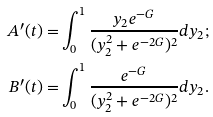Convert formula to latex. <formula><loc_0><loc_0><loc_500><loc_500>A ^ { \prime } ( t ) = & \int _ { 0 } ^ { 1 } \frac { y _ { 2 } e ^ { - G } } { ( y _ { 2 } ^ { 2 } + e ^ { - 2 G } ) ^ { 2 } } d y _ { 2 } ; \\ B ^ { \prime } ( t ) = & \int _ { 0 } ^ { 1 } \frac { e ^ { - G } } { ( y _ { 2 } ^ { 2 } + e ^ { - 2 G } ) ^ { 2 } } d y _ { 2 } .</formula> 